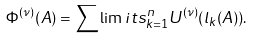<formula> <loc_0><loc_0><loc_500><loc_500>\Phi ^ { ( \nu ) } ( A ) = \sum \lim i t s _ { k = 1 } ^ { n } U ^ { ( \nu ) } ( l _ { k } ( A ) ) .</formula> 